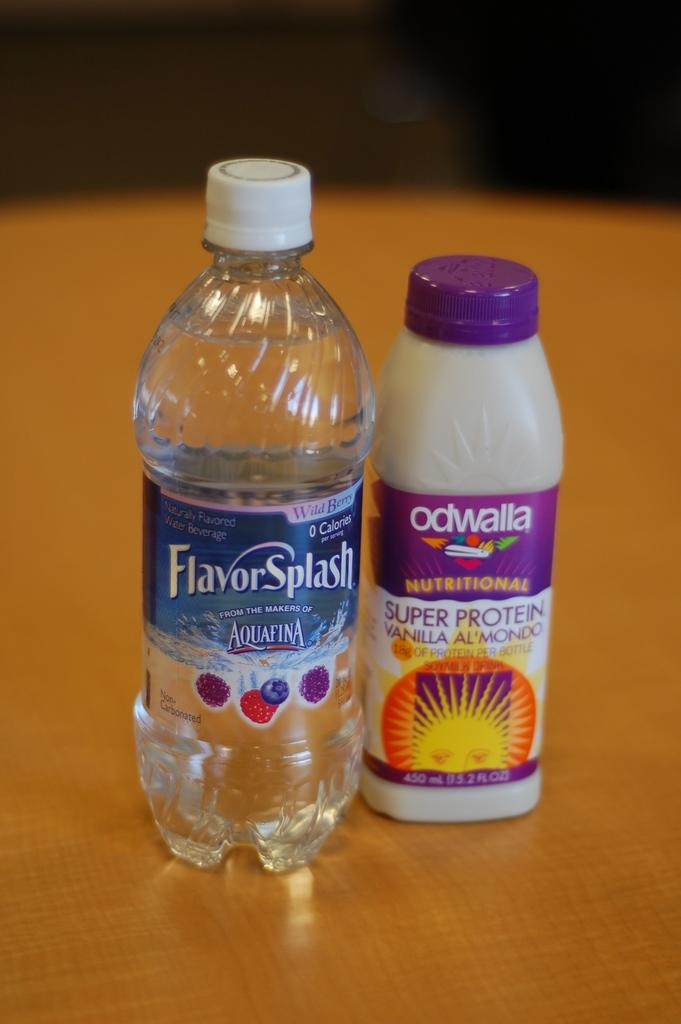How many bottles are on the table in the image? There are two bottles on the table in the image. What types of bottles are on the table? One of the bottles is a water bottle, and the other bottle is a protein bottle. Can you describe the lid of the protein bottle? The protein bottle has a blue color lid. How many times does the door fold in the image? There is no door present in the image, so it cannot be determined how many times it folds. 